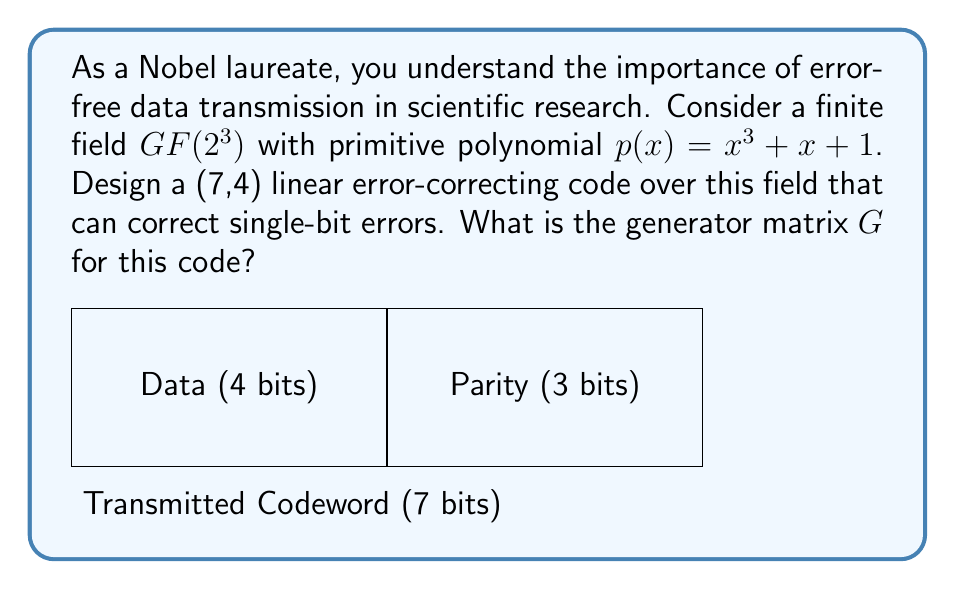Can you answer this question? To design a (7,4) linear error-correcting code over $GF(2^3)$, we follow these steps:

1) First, we need to understand the field $GF(2^3)$. It has 8 elements: {0, 1, α, α^2, α^3, α^4, α^5, α^6}, where α is a primitive element satisfying α^3 + α + 1 = 0.

2) For a (7,4) code, we need a 4x7 generator matrix G. The general form is:
   $$G = [I_4 | P]$$
   where $I_4$ is the 4x4 identity matrix and P is a 4x3 parity check matrix.

3) To correct single-bit errors, we need the columns of G to be distinct and non-zero.

4) We can choose P as follows:
   $$P = \begin{bmatrix}
   1 & 1 & 1 \\
   α & α^2 & α^4 \\
   α^2 & α^4 & α \\
   α^4 & α & α^2
   \end{bmatrix}$$

5) This choice ensures that all columns of G are distinct and non-zero in $GF(2^3)$.

6) Therefore, the generator matrix G is:
   $$G = \begin{bmatrix}
   1 & 0 & 0 & 0 & 1 & 1 & 1 \\
   0 & 1 & 0 & 0 & α & α^2 & α^4 \\
   0 & 0 & 1 & 0 & α^2 & α^4 & α \\
   0 & 0 & 0 & 1 & α^4 & α & α^2
   \end{bmatrix}$$

This generator matrix G will produce a (7,4) linear code over $GF(2^3)$ capable of correcting single-bit errors.
Answer: $$G = \begin{bmatrix}
1 & 0 & 0 & 0 & 1 & 1 & 1 \\
0 & 1 & 0 & 0 & α & α^2 & α^4 \\
0 & 0 & 1 & 0 & α^2 & α^4 & α \\
0 & 0 & 0 & 1 & α^4 & α & α^2
\end{bmatrix}$$ 